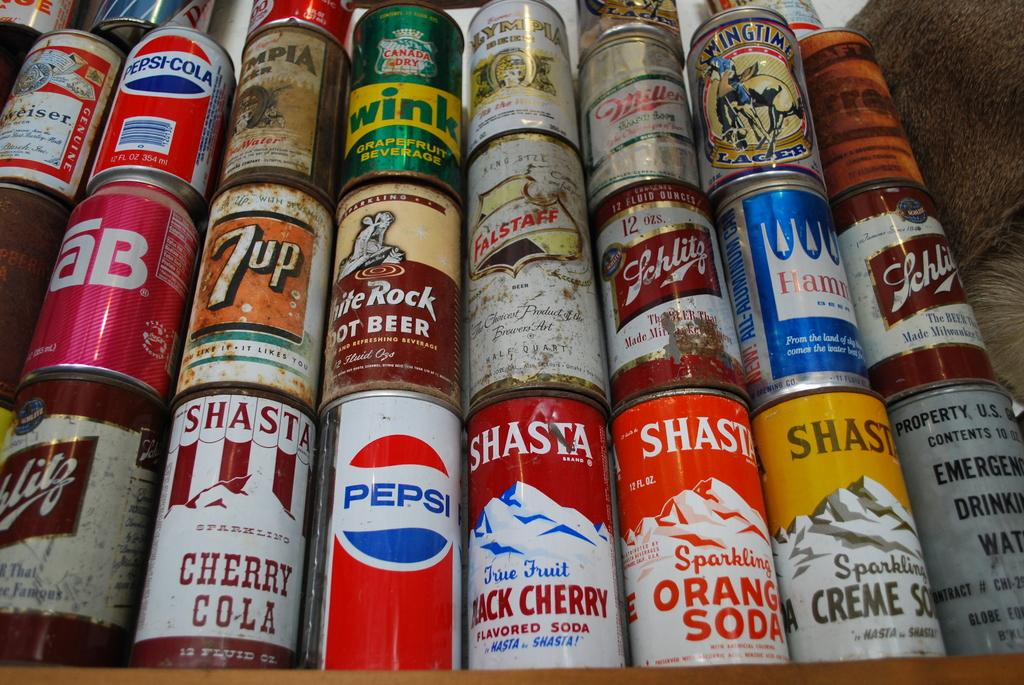<image>
Share a concise interpretation of the image provided. Several cans of varying drinks are stacked on top of each other with one being a pepsi can. 